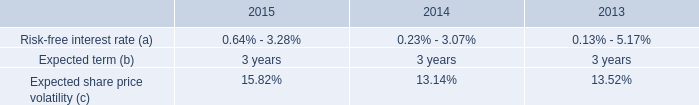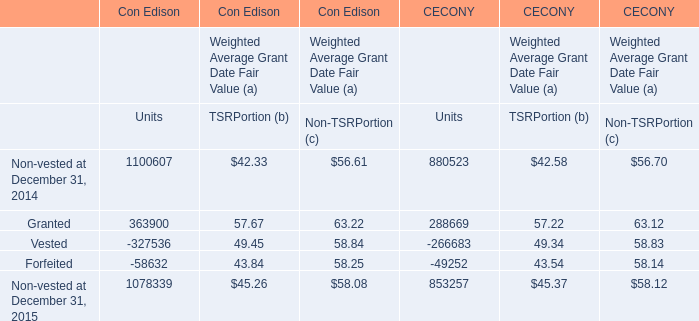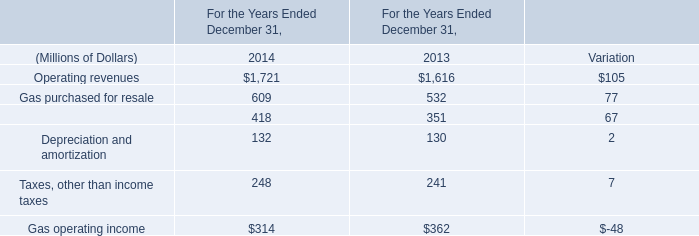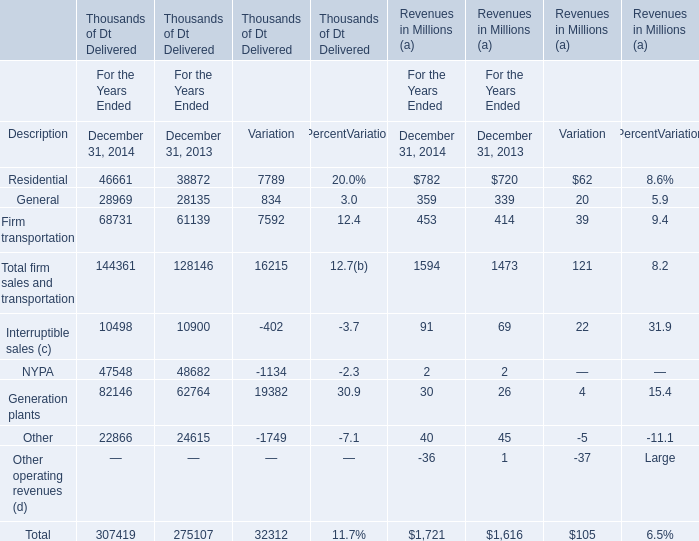What is the sum of the Firm transportation and Total firm sales and transportation in the years where General forThousands of Dt Delivered is greater than 28000? (in thousand) 
Computations: (68731 + 144361)
Answer: 213092.0. 